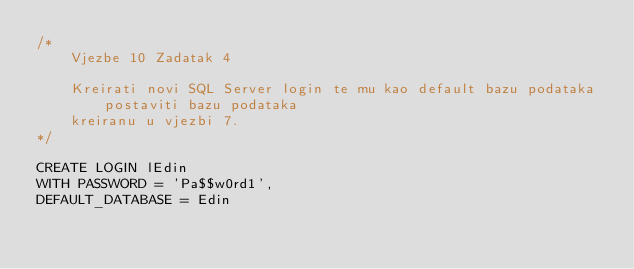<code> <loc_0><loc_0><loc_500><loc_500><_SQL_>/*
	Vjezbe 10 Zadatak 4

	Kreirati novi SQL Server login te mu kao default bazu podataka postaviti bazu podataka 
	kreiranu u vjezbi 7. 
*/

CREATE LOGIN lEdin
WITH PASSWORD = 'Pa$$w0rd1',
DEFAULT_DATABASE = Edin
</code> 